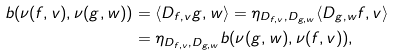<formula> <loc_0><loc_0><loc_500><loc_500>b ( \nu ( f , v ) , \nu ( g , w ) ) & = \langle D _ { f , v } g , w \rangle = \eta _ { D _ { f , v } , D _ { g , w } } \langle D _ { g , w } f , v \rangle \\ & = \eta _ { D _ { f , v } , D _ { g , w } } b ( \nu ( g , w ) , \nu ( f , v ) ) ,</formula> 